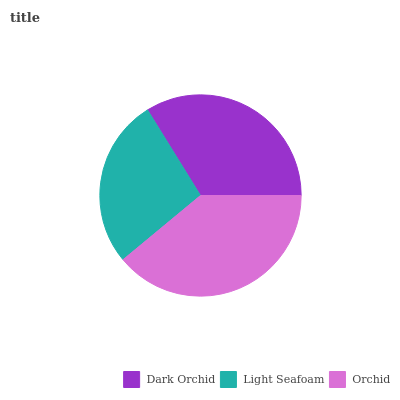Is Light Seafoam the minimum?
Answer yes or no. Yes. Is Orchid the maximum?
Answer yes or no. Yes. Is Orchid the minimum?
Answer yes or no. No. Is Light Seafoam the maximum?
Answer yes or no. No. Is Orchid greater than Light Seafoam?
Answer yes or no. Yes. Is Light Seafoam less than Orchid?
Answer yes or no. Yes. Is Light Seafoam greater than Orchid?
Answer yes or no. No. Is Orchid less than Light Seafoam?
Answer yes or no. No. Is Dark Orchid the high median?
Answer yes or no. Yes. Is Dark Orchid the low median?
Answer yes or no. Yes. Is Light Seafoam the high median?
Answer yes or no. No. Is Orchid the low median?
Answer yes or no. No. 